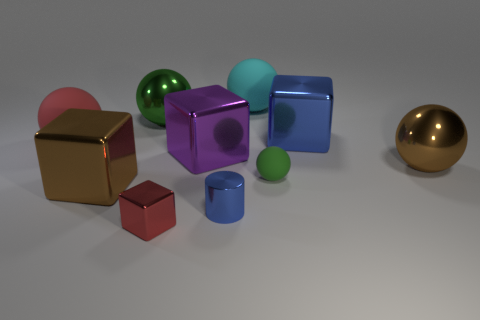Subtract all red spheres. How many spheres are left? 4 Subtract all large brown metal balls. How many balls are left? 4 Subtract all yellow balls. Subtract all cyan cylinders. How many balls are left? 5 Subtract all cylinders. How many objects are left? 9 Add 3 tiny yellow metallic cylinders. How many tiny yellow metallic cylinders exist? 3 Subtract 0 brown cylinders. How many objects are left? 10 Subtract all large blue cubes. Subtract all green rubber objects. How many objects are left? 8 Add 8 small blue cylinders. How many small blue cylinders are left? 9 